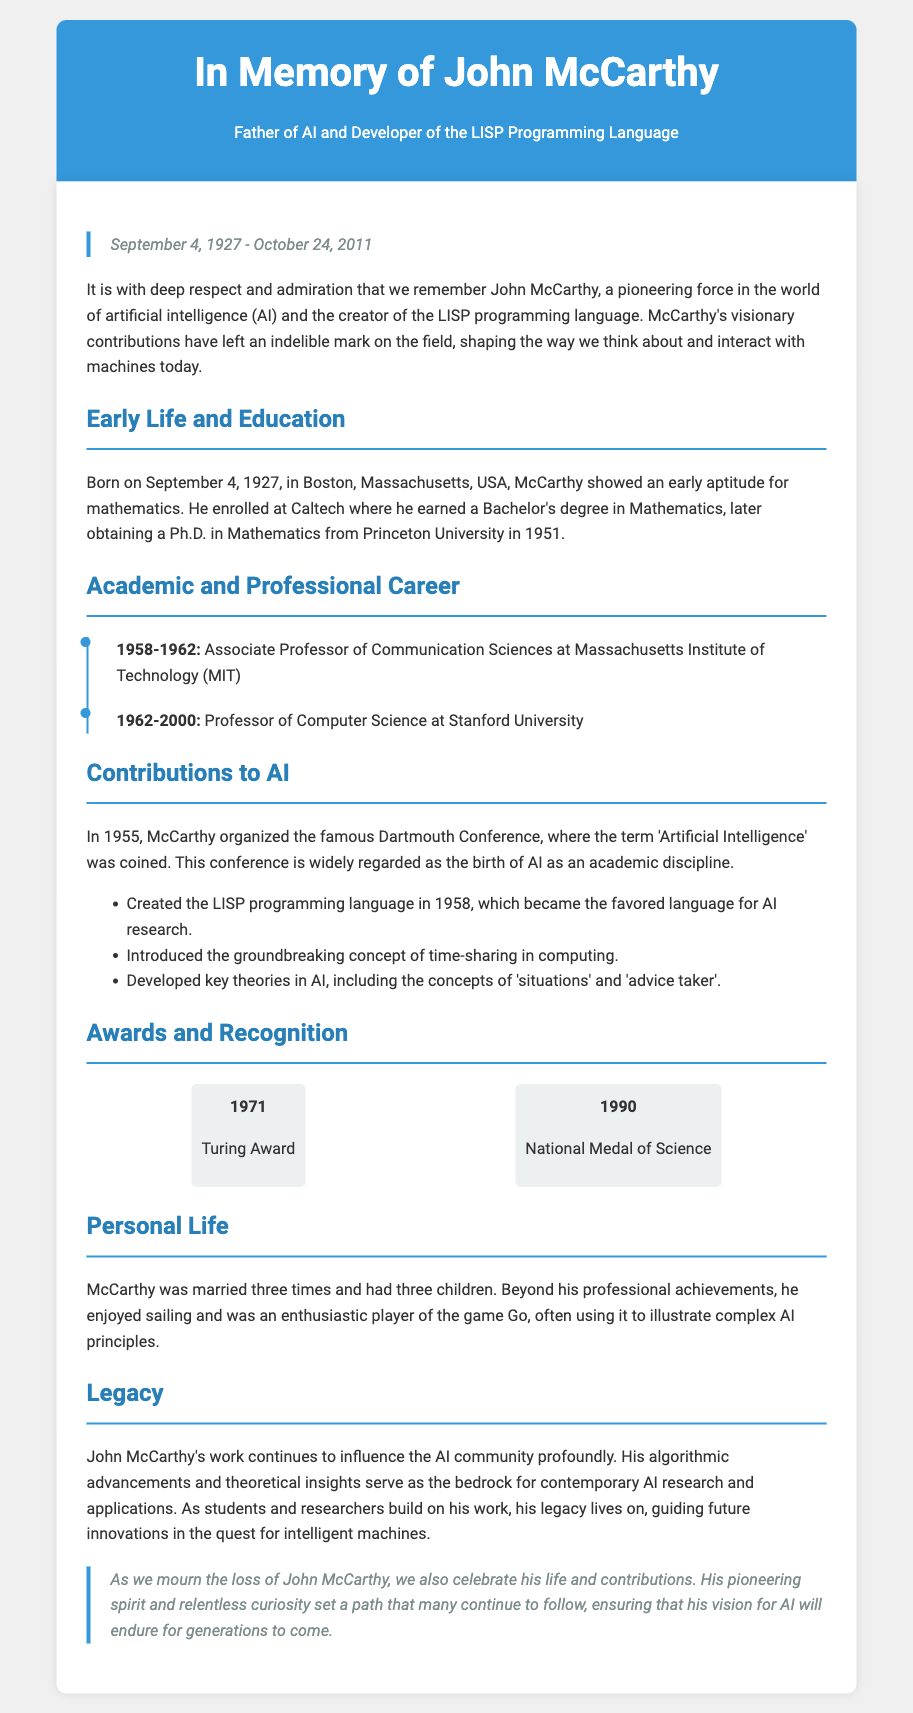What date was John McCarthy born? The document states that John McCarthy was born on September 4, 1927.
Answer: September 4, 1927 What degree did McCarthy obtain from Princeton University? According to the document, McCarthy earned a Ph.D. in Mathematics from Princeton University in 1951.
Answer: Ph.D. in Mathematics What significant event did McCarthy organize in 1955? The document mentions that McCarthy organized the Dartmouth Conference in 1955, where the term 'Artificial Intelligence' was coined.
Answer: Dartmouth Conference Which programming language did McCarthy create? The document indicates that McCarthy created the LISP programming language in 1958, which became the favored language for AI research.
Answer: LISP How many children did McCarthy have? According to the document, McCarthy had three children.
Answer: three What notable award did McCarthy receive in 1971? The document highlights that McCarthy received the Turing Award in 1971.
Answer: Turing Award In which year did McCarthy pass away? The document states that John McCarthy passed away on October 24, 2011.
Answer: October 24, 2011 What is described as a significant aspect of McCarthy's legacy? The document states that John McCarthy's work continues to influence the AI community profoundly.
Answer: influence on AI community 